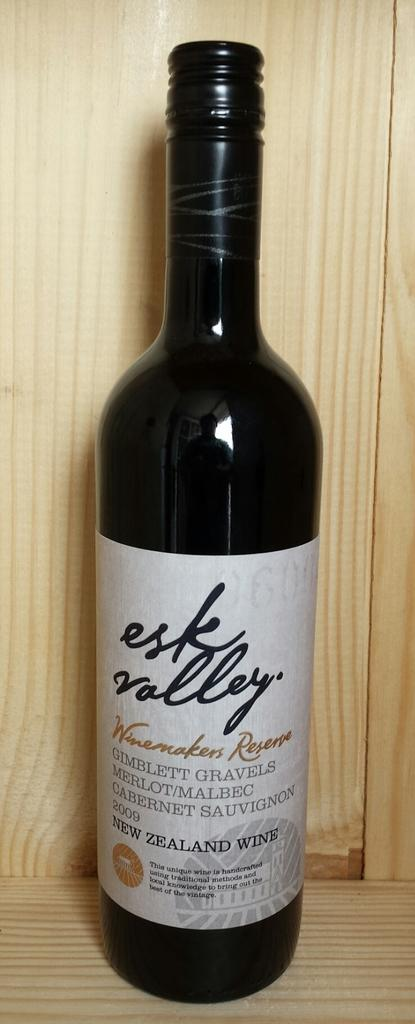Provide a one-sentence caption for the provided image. Bottle of New ZealandWine esk valley that is new. 